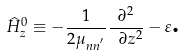<formula> <loc_0><loc_0><loc_500><loc_500>\widehat { H } _ { z } ^ { 0 } \equiv - \frac { 1 } { 2 \mu _ { n n ^ { ^ { \prime } } } } \frac { \partial ^ { 2 } } { \ \partial z ^ { 2 } } - \varepsilon \text {.}</formula> 